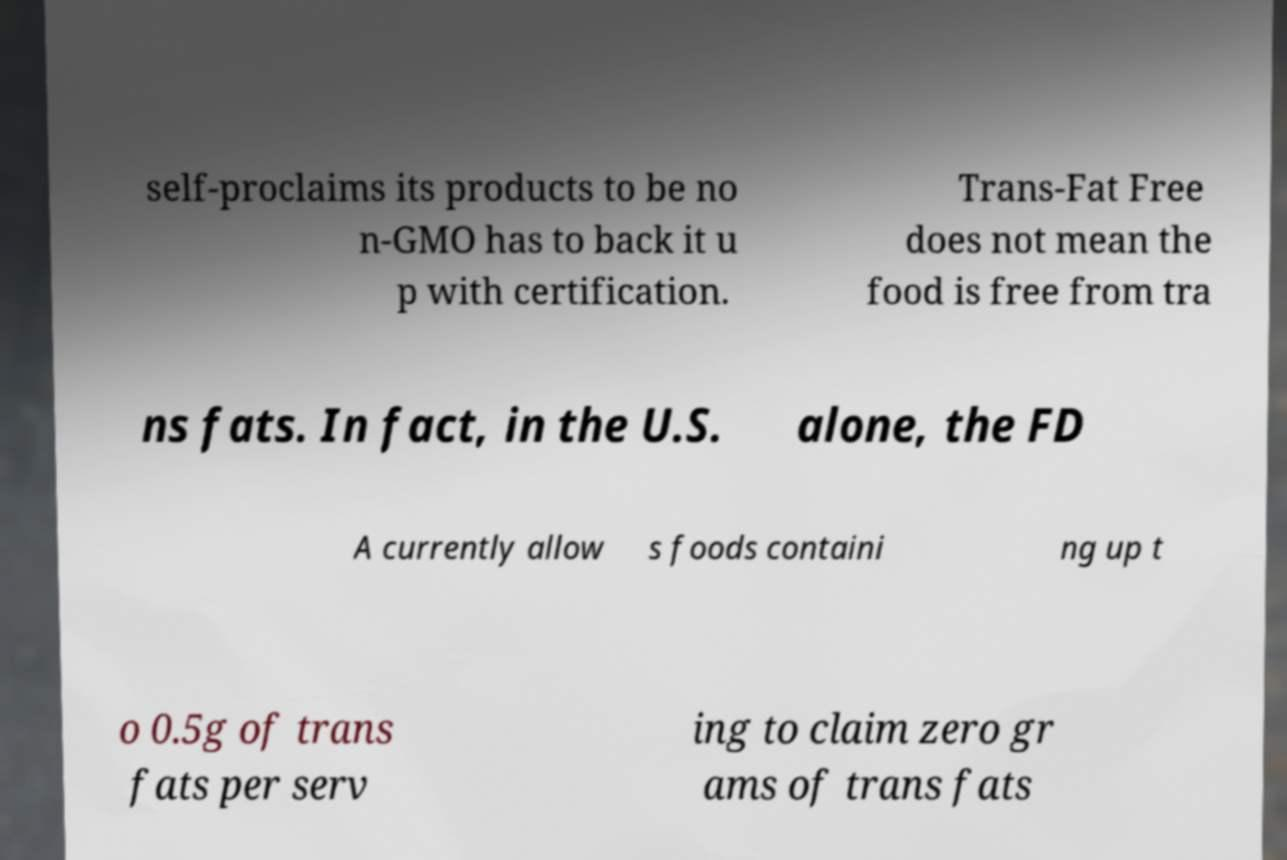Please read and relay the text visible in this image. What does it say? self-proclaims its products to be no n-GMO has to back it u p with certification. Trans-Fat Free does not mean the food is free from tra ns fats. In fact, in the U.S. alone, the FD A currently allow s foods containi ng up t o 0.5g of trans fats per serv ing to claim zero gr ams of trans fats 